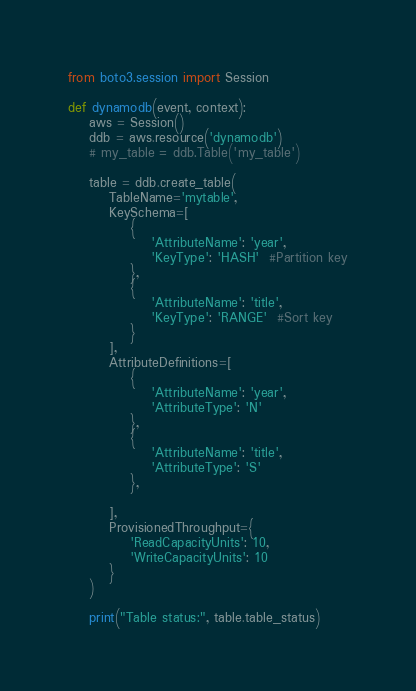<code> <loc_0><loc_0><loc_500><loc_500><_Python_>from boto3.session import Session

def dynamodb(event, context):
    aws = Session()
    ddb = aws.resource('dynamodb')
    # my_table = ddb.Table('my_table')

    table = ddb.create_table(
        TableName='mytable',
        KeySchema=[
            {
                'AttributeName': 'year',
                'KeyType': 'HASH'  #Partition key
            },
            {
                'AttributeName': 'title',
                'KeyType': 'RANGE'  #Sort key
            }
        ],
        AttributeDefinitions=[
            {
                'AttributeName': 'year',
                'AttributeType': 'N'
            },
            {
                'AttributeName': 'title',
                'AttributeType': 'S'
            },

        ],
        ProvisionedThroughput={
            'ReadCapacityUnits': 10,
            'WriteCapacityUnits': 10
        }
    )

    print("Table status:", table.table_status)
</code> 